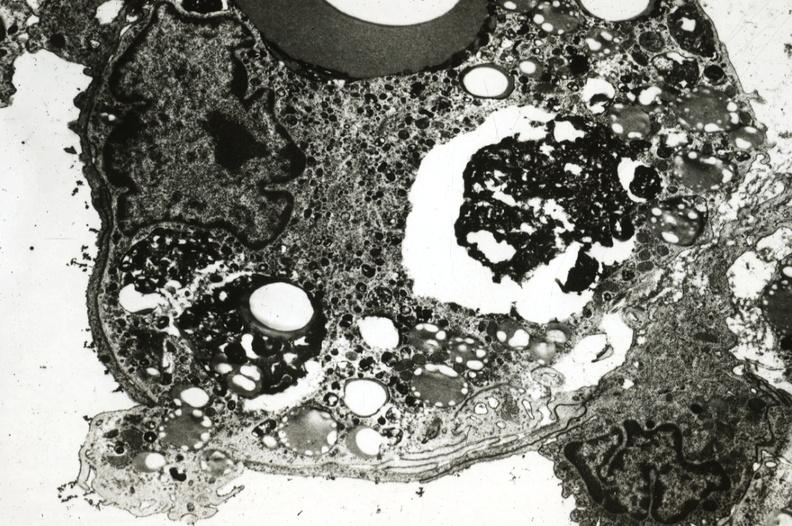what is present?
Answer the question using a single word or phrase. Atherosclerosis 